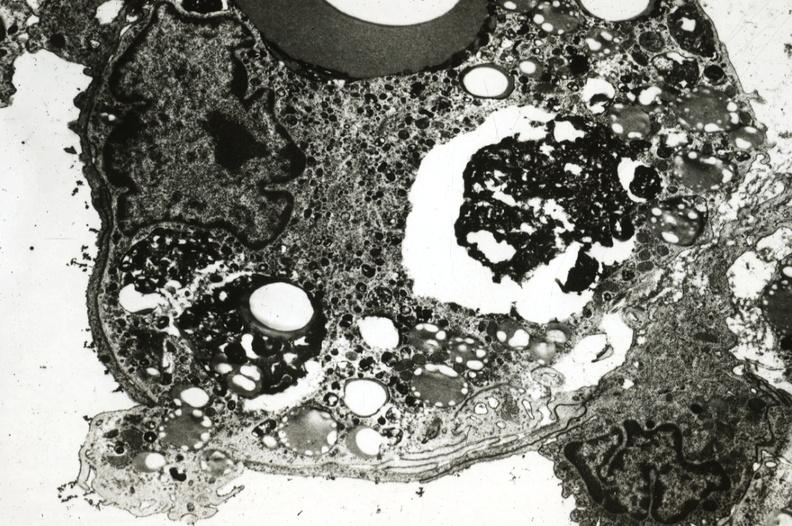what is present?
Answer the question using a single word or phrase. Atherosclerosis 